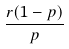Convert formula to latex. <formula><loc_0><loc_0><loc_500><loc_500>\frac { r ( 1 - p ) } { p }</formula> 